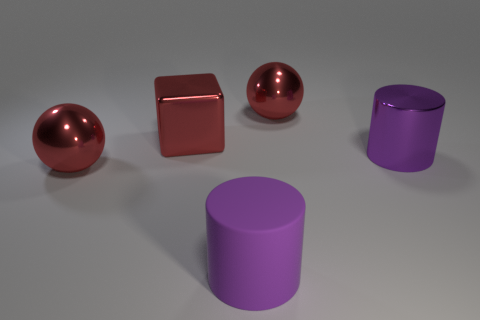Add 5 big red shiny cubes. How many objects exist? 10 Subtract all cylinders. How many objects are left? 3 Subtract 2 purple cylinders. How many objects are left? 3 Subtract all large metal spheres. Subtract all large purple cylinders. How many objects are left? 1 Add 4 balls. How many balls are left? 6 Add 4 big cyan metallic blocks. How many big cyan metallic blocks exist? 4 